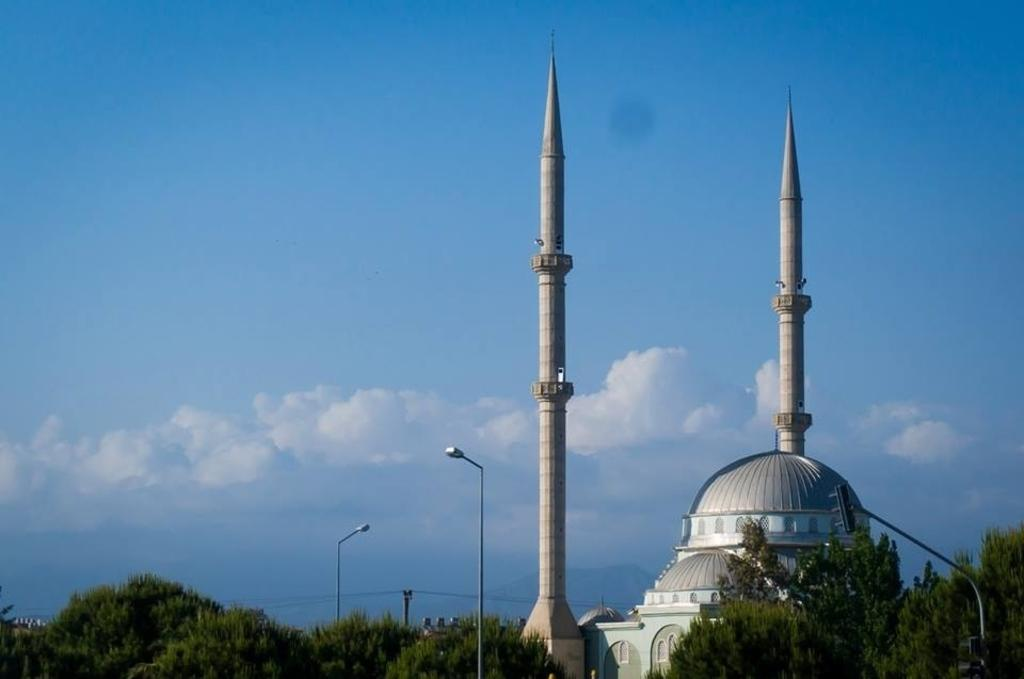What type of structure is present in the image? There is a minaret in the image. What else can be seen in the image besides the minaret? There are poles with lights attached to them in the image. What type of vegetation is visible at the bottom of the image? Trees are visible at the bottom of the image. What part of the natural environment is visible in the image? The sky is visible in the middle of the image. Where is the plate located in the image? There is no plate present in the image. What type of tent can be seen in the image? There is no tent present in the image. 